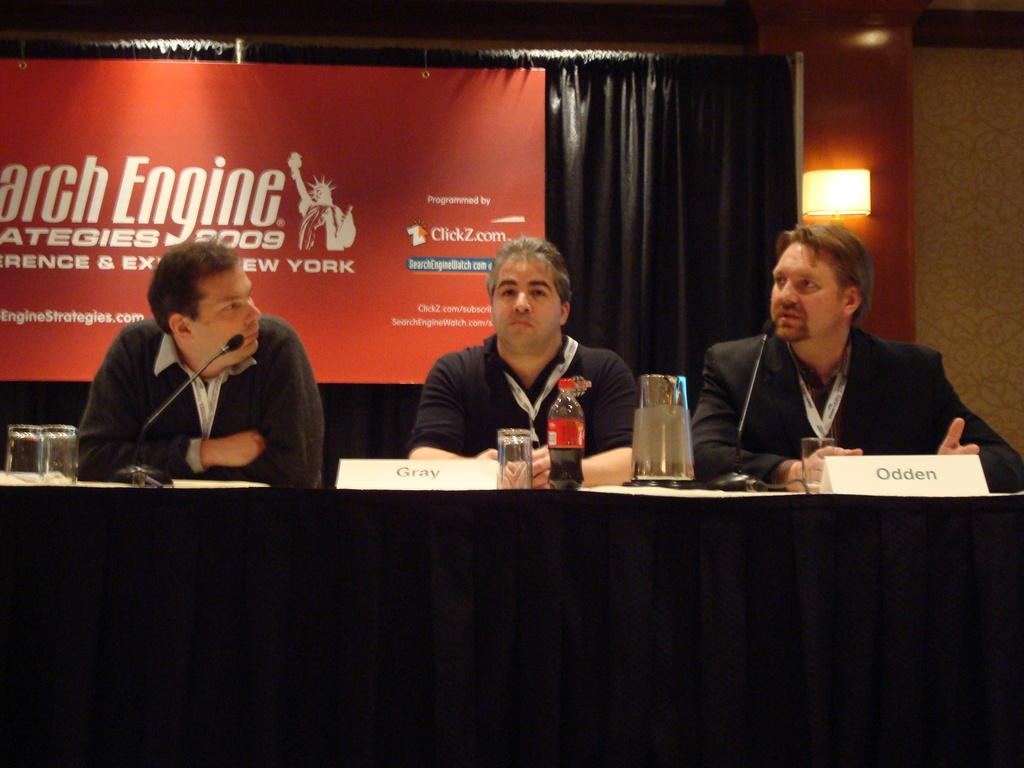<image>
Summarize the visual content of the image. Three men are sitting at a table at the Search Engine strategies 2009 panel. 